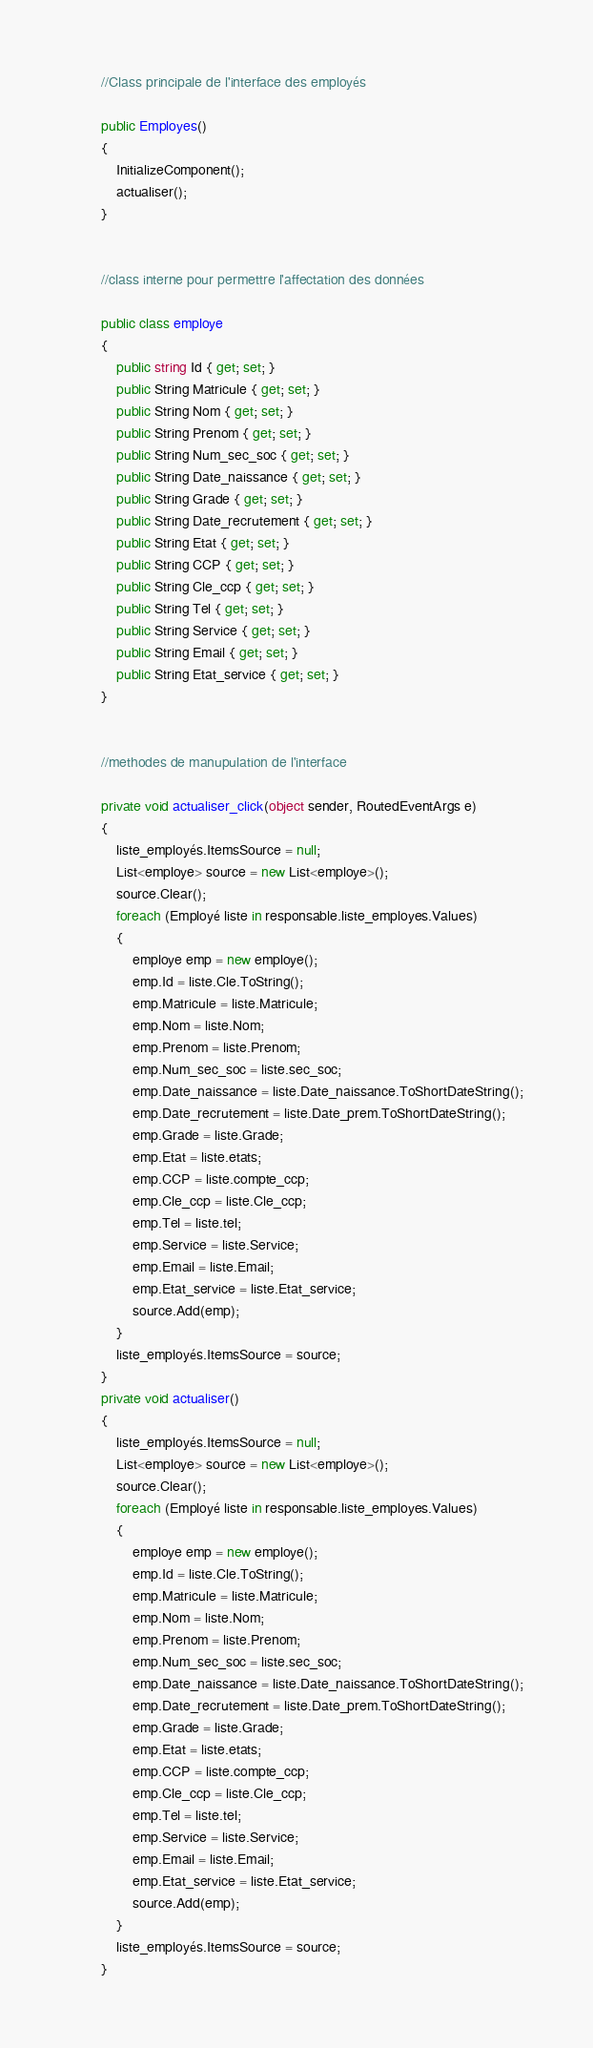Convert code to text. <code><loc_0><loc_0><loc_500><loc_500><_C#_>        //Class principale de l'interface des employés

        public Employes()
        {
            InitializeComponent();
            actualiser();
        }


        //class interne pour permettre l'affectation des données

        public class employe
        {
            public string Id { get; set; }
            public String Matricule { get; set; }
            public String Nom { get; set; }
            public String Prenom { get; set; }
            public String Num_sec_soc { get; set; }
            public String Date_naissance { get; set; }
            public String Grade { get; set; }
            public String Date_recrutement { get; set; }
            public String Etat { get; set; }
            public String CCP { get; set; }
            public String Cle_ccp { get; set; }
            public String Tel { get; set; }            
            public String Service { get; set; }
            public String Email { get; set; }
            public String Etat_service { get; set; }
        }


        //methodes de manupulation de l'interface

        private void actualiser_click(object sender, RoutedEventArgs e)
        {
            liste_employés.ItemsSource = null;
            List<employe> source = new List<employe>();
            source.Clear();
            foreach (Employé liste in responsable.liste_employes.Values)
            {
                employe emp = new employe();
                emp.Id = liste.Cle.ToString();
                emp.Matricule = liste.Matricule;
                emp.Nom = liste.Nom;
                emp.Prenom = liste.Prenom;
                emp.Num_sec_soc = liste.sec_soc;
                emp.Date_naissance = liste.Date_naissance.ToShortDateString();
                emp.Date_recrutement = liste.Date_prem.ToShortDateString();
                emp.Grade = liste.Grade;
                emp.Etat = liste.etats;
                emp.CCP = liste.compte_ccp;
                emp.Cle_ccp = liste.Cle_ccp;
                emp.Tel = liste.tel;
                emp.Service = liste.Service;
                emp.Email = liste.Email;
                emp.Etat_service = liste.Etat_service;
                source.Add(emp);
            }
            liste_employés.ItemsSource = source;
        }
        private void actualiser()
        {
            liste_employés.ItemsSource = null;
            List<employe> source = new List<employe>();
            source.Clear();
            foreach (Employé liste in responsable.liste_employes.Values)
            {
                employe emp = new employe();
                emp.Id = liste.Cle.ToString();
                emp.Matricule = liste.Matricule;
                emp.Nom = liste.Nom;
                emp.Prenom = liste.Prenom;
                emp.Num_sec_soc = liste.sec_soc;
                emp.Date_naissance = liste.Date_naissance.ToShortDateString();
                emp.Date_recrutement = liste.Date_prem.ToShortDateString();
                emp.Grade = liste.Grade;
                emp.Etat = liste.etats;
                emp.CCP = liste.compte_ccp;
                emp.Cle_ccp = liste.Cle_ccp;
                emp.Tel = liste.tel;
                emp.Service = liste.Service;
                emp.Email = liste.Email;
                emp.Etat_service = liste.Etat_service;
                source.Add(emp);
            }
            liste_employés.ItemsSource = source;
        }
</code> 